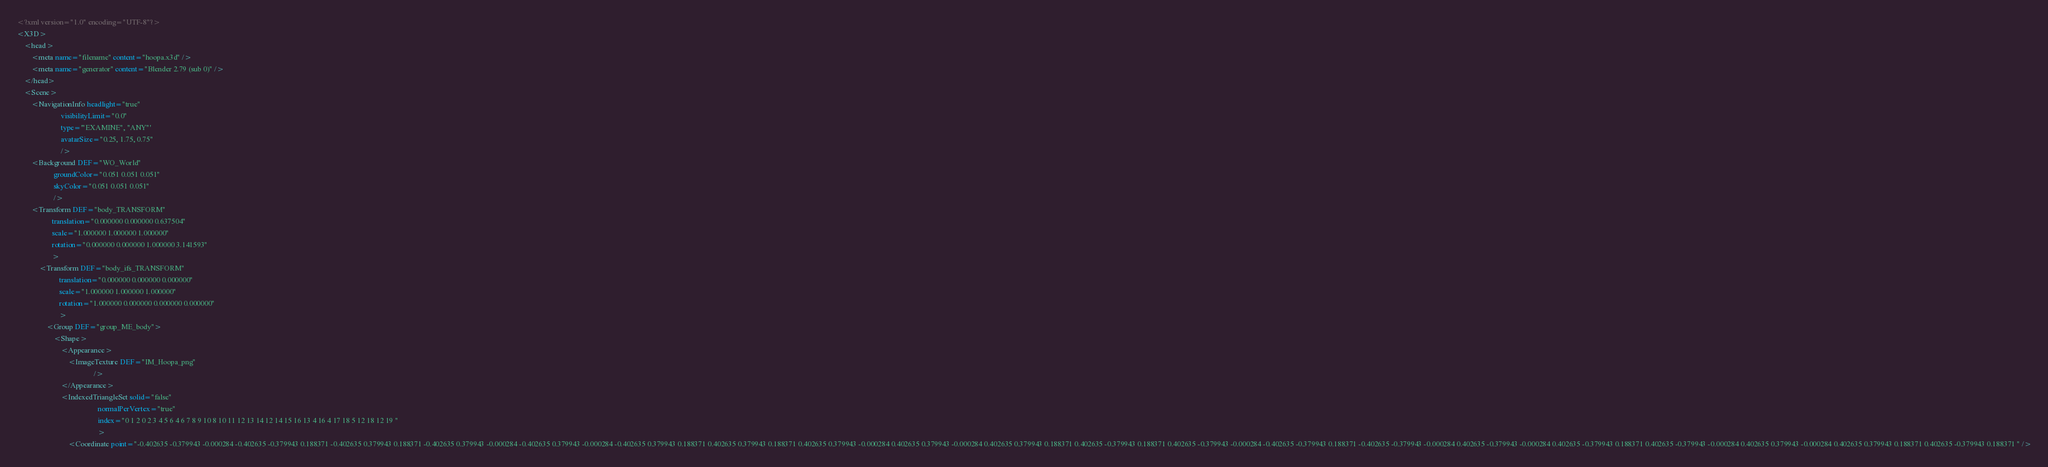<code> <loc_0><loc_0><loc_500><loc_500><_XML_><?xml version="1.0" encoding="UTF-8"?>
<X3D>
	<head>
		<meta name="filename" content="hoopa.x3d" />
		<meta name="generator" content="Blender 2.79 (sub 0)" />
	</head>
	<Scene>
		<NavigationInfo headlight="true"
		                visibilityLimit="0.0"
		                type='"EXAMINE", "ANY"'
		                avatarSize="0.25, 1.75, 0.75"
		                />
		<Background DEF="WO_World"
		            groundColor="0.051 0.051 0.051"
		            skyColor="0.051 0.051 0.051"
		            />
		<Transform DEF="body_TRANSFORM"
		           translation="0.000000 0.000000 0.637504"
		           scale="1.000000 1.000000 1.000000"
		           rotation="0.000000 0.000000 1.000000 3.141593"
		           >
			<Transform DEF="body_ifs_TRANSFORM"
			           translation="0.000000 0.000000 0.000000"
			           scale="1.000000 1.000000 1.000000"
			           rotation="1.000000 0.000000 0.000000 0.000000"
			           >
				<Group DEF="group_ME_body">
					<Shape>
						<Appearance>
							<ImageTexture DEF="IM_Hoopa_png"
							              />
						</Appearance>
						<IndexedTriangleSet solid="false"
						                    normalPerVertex="true"
						                    index="0 1 2 0 2 3 4 5 6 4 6 7 8 9 10 8 10 11 12 13 14 12 14 15 16 13 4 16 4 17 18 5 12 18 12 19 "
						                    >
							<Coordinate point="-0.402635 -0.379943 -0.000284 -0.402635 -0.379943 0.188371 -0.402635 0.379943 0.188371 -0.402635 0.379943 -0.000284 -0.402635 0.379943 -0.000284 -0.402635 0.379943 0.188371 0.402635 0.379943 0.188371 0.402635 0.379943 -0.000284 0.402635 0.379943 -0.000284 0.402635 0.379943 0.188371 0.402635 -0.379943 0.188371 0.402635 -0.379943 -0.000284 -0.402635 -0.379943 0.188371 -0.402635 -0.379943 -0.000284 0.402635 -0.379943 -0.000284 0.402635 -0.379943 0.188371 0.402635 -0.379943 -0.000284 0.402635 0.379943 -0.000284 0.402635 0.379943 0.188371 0.402635 -0.379943 0.188371 " /></code> 